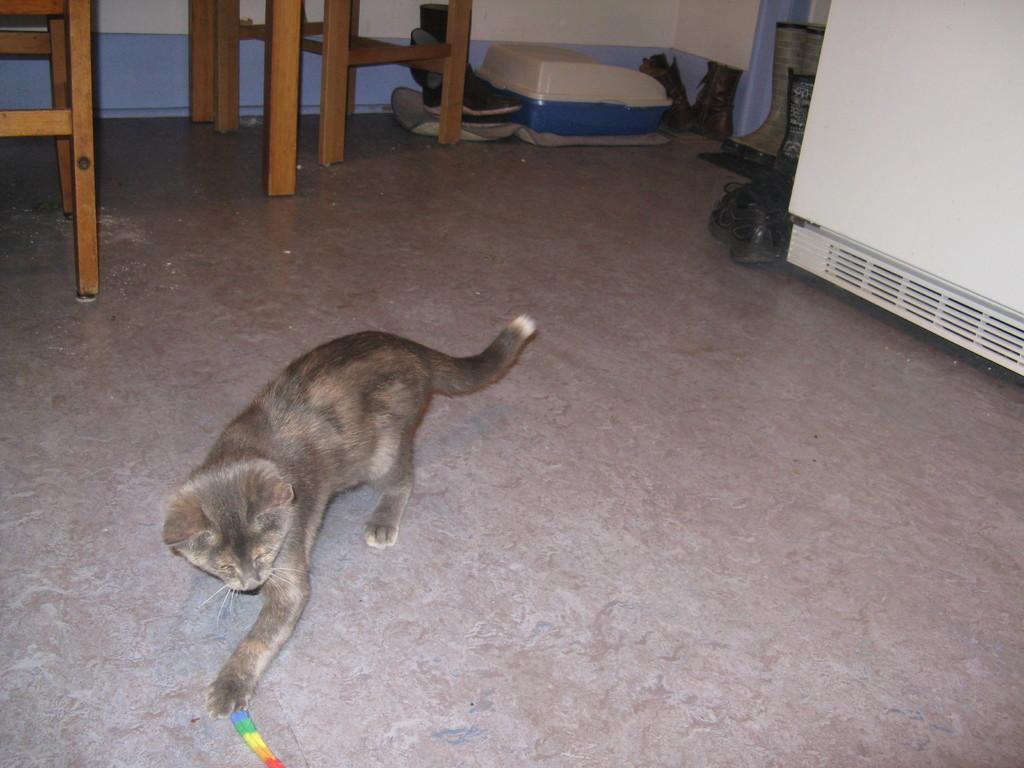What type of animal is in the image? There is a cat in the image. Can you describe the color of the cat? The cat is black and brown in color. What can be seen in the background of the image? There are objects visible in the background. What type of objects are on the floor in the image? There are shoes and wooden objects on the floor. How does the cat draw the attention of the rock in the image? There is no rock present in the image, so it is not possible to determine how the cat might draw its attention. 